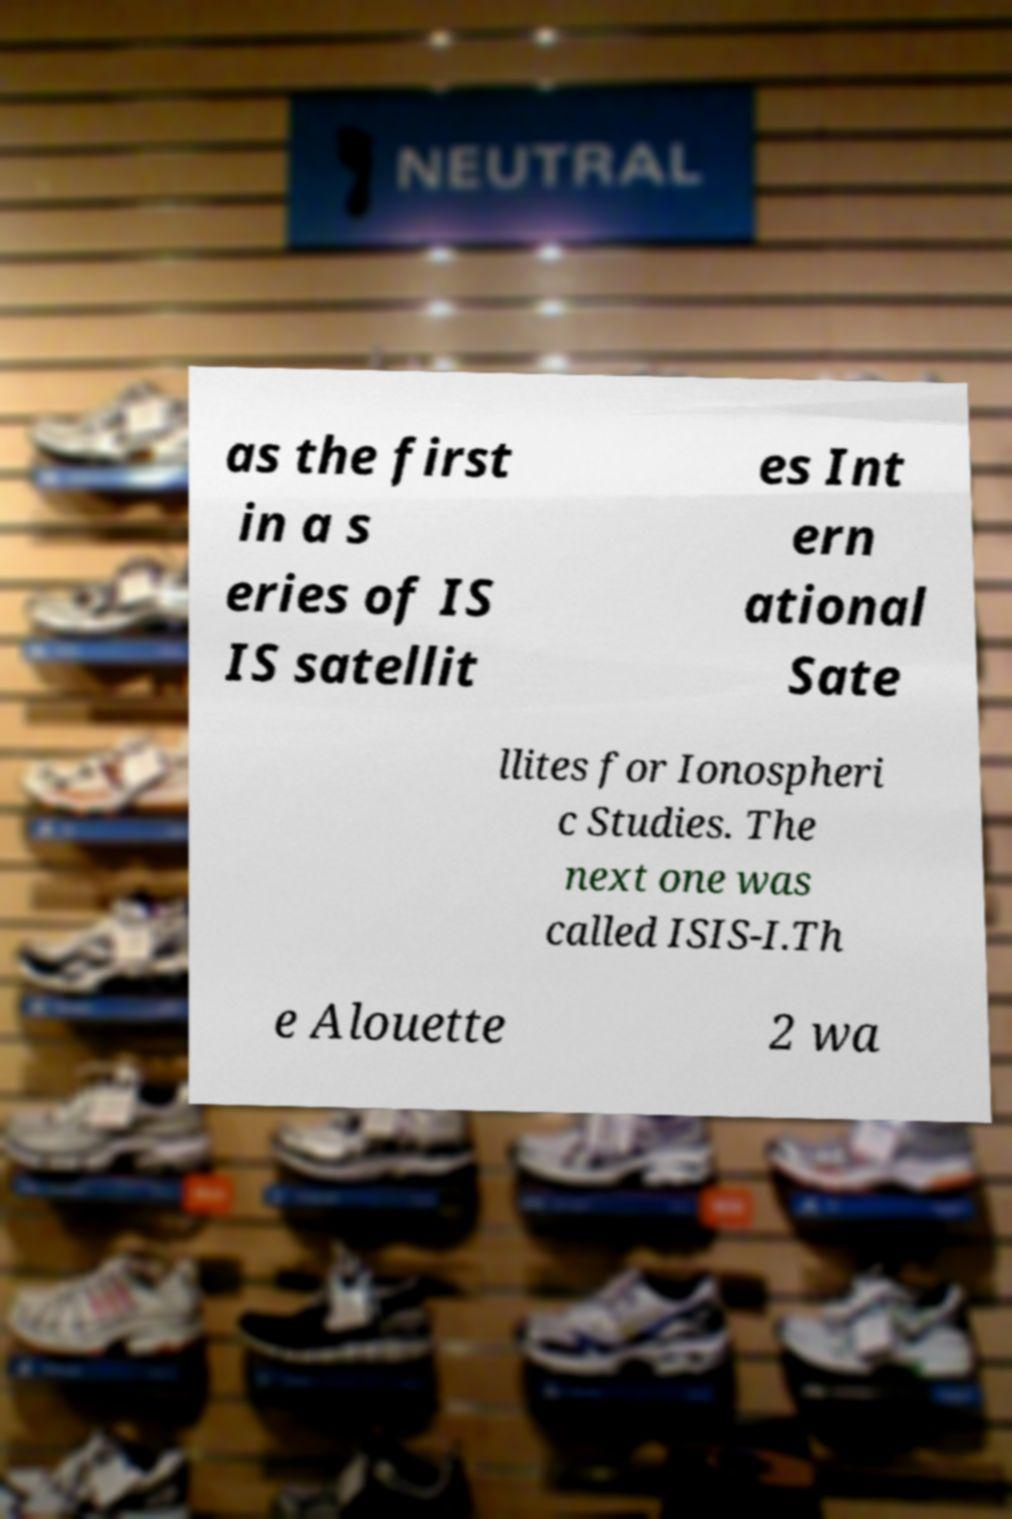I need the written content from this picture converted into text. Can you do that? as the first in a s eries of IS IS satellit es Int ern ational Sate llites for Ionospheri c Studies. The next one was called ISIS-I.Th e Alouette 2 wa 